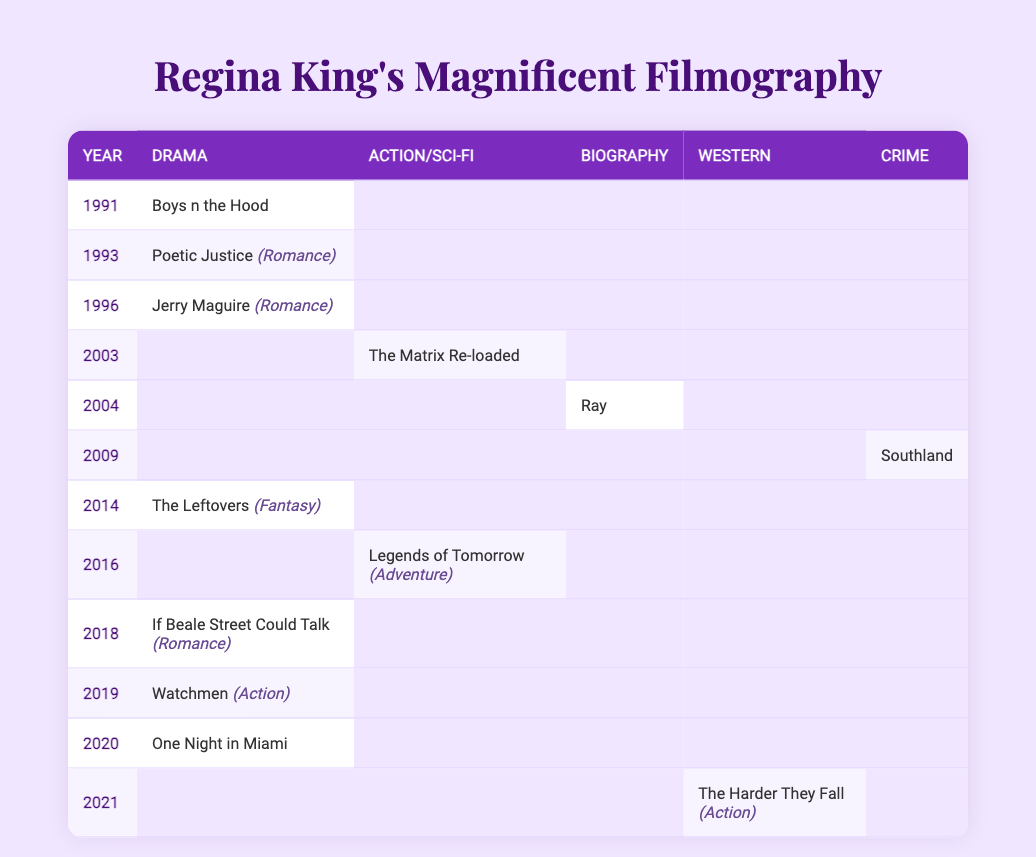What is the earliest film listed in Regina King's filmography? The table shows that the earliest film in Regina King's filmography under the Drama genre is "Boys n the Hood," which was released in 1991.
Answer: Boys n the Hood How many films did Regina King appear in during the year 2004? In the year 2004, Regina King appeared in only one film, "Ray," which is categorized under Biography/Drama.
Answer: 1 Which genre has the most films in Regina King's filmography according to the table? By reviewing the table, the Drama genre has the most entries with a total of 6 films listed across various years.
Answer: Drama Is "The Matrix Re-loaded" a Drama film? Referring to the genre column in the table, "The Matrix Re-loaded" is categorized under Action/Sci-Fi, so it is not a Drama film.
Answer: No In which year did Regina King feature in a film with a genre classified as Western? The only film categorized as Western in the table is "The Harder They Fall," released in 2021.
Answer: 2021 How many films in the table are listed as having a Romance element? The table shows that there are 3 films with a Romance element: "Poetic Justice," "Jerry Maguire," and "If Beale Street Could Talk."
Answer: 3 Which two films released in 2018 and 2019 fall under the Drama genre? In the table, "If Beale Street Could Talk" (2018) and "Watchmen" (2019) are both categorized under Drama.
Answer: If Beale Street Could Talk and Watchmen What is the average release year of the films categorized as Action/Sci-Fi? There is only one Action/Sci-Fi film in the table, "The Matrix Re-loaded," released in 2003, which makes the average year 2003 itself.
Answer: 2003 Which genre does "Southland" belong to? According to the genre column in the table, "Southland" is classified as a Crime/Drama film.
Answer: Crime/Drama How many unique genres are represented in Regina King's filmography based on the table? By reviewing the table, there are a total of 6 unique genres: Drama, Action/Sci-Fi, Biography, Western, Crime, and Action/Adventure.
Answer: 6 